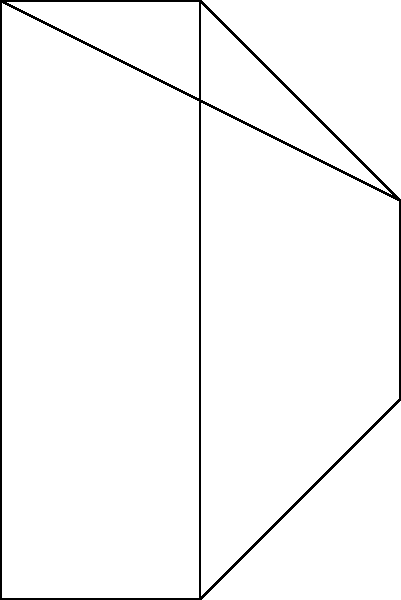As a chemist, analyze the 2D structural formula and its corresponding 3D representation of a cyclic organic compound shown above. What is the most likely molecular formula of this compound, assuming it follows standard valence rules and contains only carbon and hydrogen atoms? To determine the molecular formula, let's follow these steps:

1. Count the number of vertices in the 2D structure, which represents carbon atoms:
   There are 6 vertices, so we have 6 carbon atoms.

2. Examine the bonds:
   - There are 7 single bonds (edges) in the 2D structure.
   - The 3D structure shows an additional dashed line, indicating a bond coming out of the plane.
   This suggests a total of 8 bonds.

3. Calculate the number of hydrogen atoms:
   - Each carbon typically forms 4 bonds (tetravalent).
   - Total bonds for 6 carbons: $6 \times 4 = 24$
   - Bonds between carbons: 8
   - Remaining bonds for hydrogen: $24 - 8 = 16$

4. Formulate the molecular formula:
   - 6 carbon atoms
   - 16 hydrogen atoms

Therefore, the most likely molecular formula is $C_6H_{16}$.

5. Verify the formula:
   This formula represents a saturated cyclic hydrocarbon, which is consistent with the structure shown.
Answer: $C_6H_{16}$ 